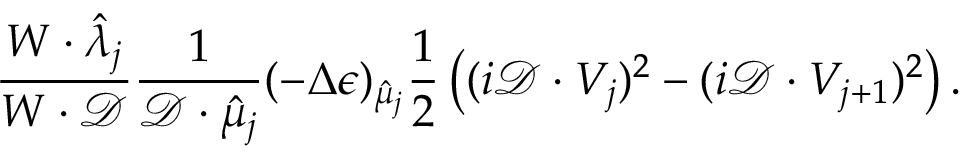<formula> <loc_0><loc_0><loc_500><loc_500>\frac { W \cdot \hat { \lambda } _ { j } } { W \cdot \mathcal { D } } \frac { 1 } { \mathcal { D } \cdot \hat { \mu } _ { j } } ( - \Delta \epsilon ) _ { \hat { \mu } _ { j } } \frac { 1 } { 2 } \left ( ( i \mathcal { D } \cdot V _ { j } ) ^ { 2 } - ( i \mathcal { D } \cdot V _ { j + 1 } ) ^ { 2 } \right ) .</formula> 